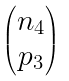Convert formula to latex. <formula><loc_0><loc_0><loc_500><loc_500>\begin{pmatrix} n _ { 4 } \\ p _ { 3 } \end{pmatrix}</formula> 